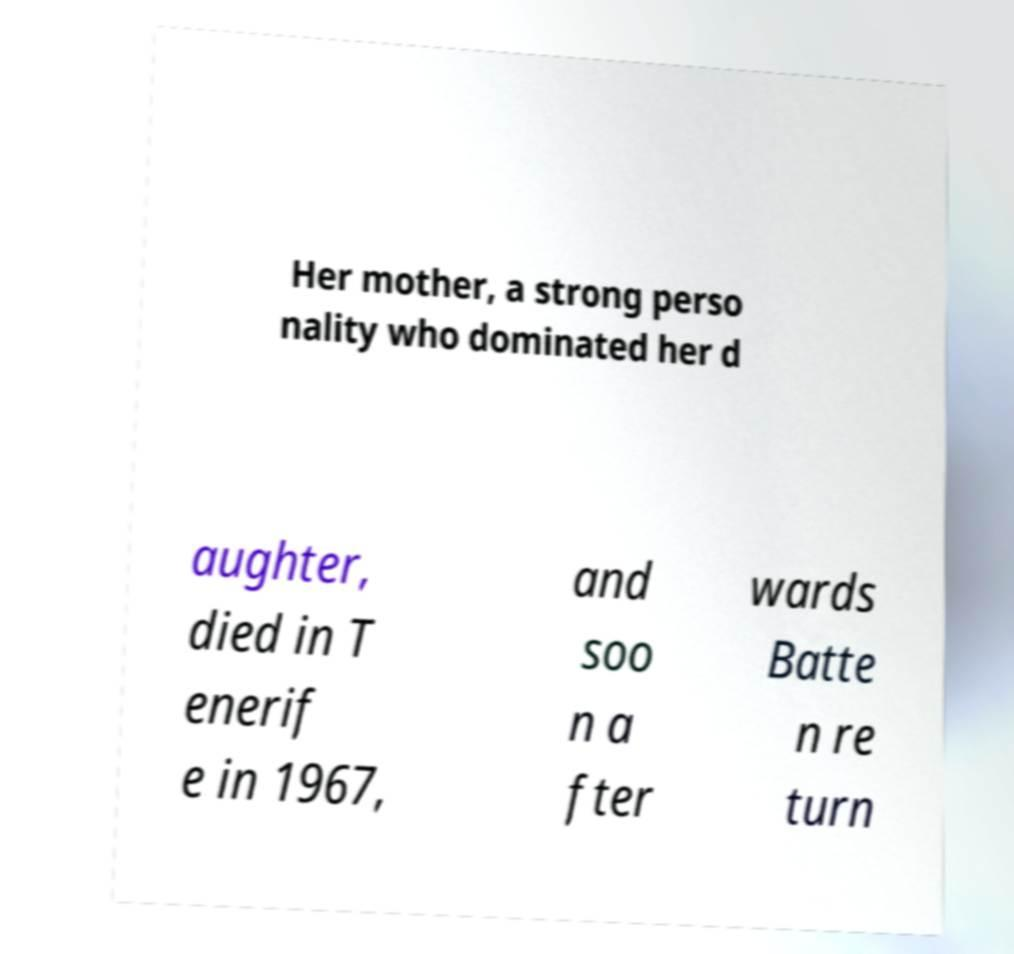Can you read and provide the text displayed in the image?This photo seems to have some interesting text. Can you extract and type it out for me? Her mother, a strong perso nality who dominated her d aughter, died in T enerif e in 1967, and soo n a fter wards Batte n re turn 